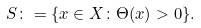<formula> <loc_0><loc_0><loc_500><loc_500>{ S } \colon = \{ x \in X \colon \Theta ( x ) > 0 \} .</formula> 